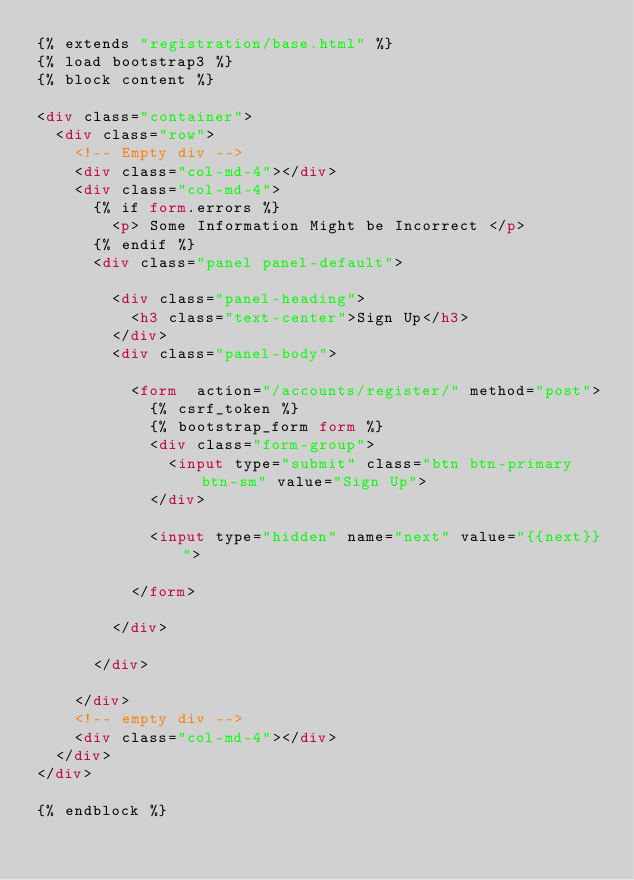Convert code to text. <code><loc_0><loc_0><loc_500><loc_500><_HTML_>{% extends "registration/base.html" %} 
{% load bootstrap3 %}
{% block content %}

<div class="container">
  <div class="row">
    <!-- Empty div -->
    <div class="col-md-4"></div>
    <div class="col-md-4">
      {% if form.errors %}
        <p> Some Information Might be Incorrect </p>
      {% endif %}
      <div class="panel panel-default">

        <div class="panel-heading">
          <h3 class="text-center">Sign Up</h3>
        </div>
        <div class="panel-body">

          <form  action="/accounts/register/" method="post">
            {% csrf_token %}
            {% bootstrap_form form %}
            <div class="form-group">
              <input type="submit" class="btn btn-primary btn-sm" value="Sign Up">
            </div>

            <input type="hidden" name="next" value="{{next}}">

          </form>

        </div>

      </div>

    </div>
    <!-- empty div -->
    <div class="col-md-4"></div>
  </div>
</div>

{% endblock %}</code> 